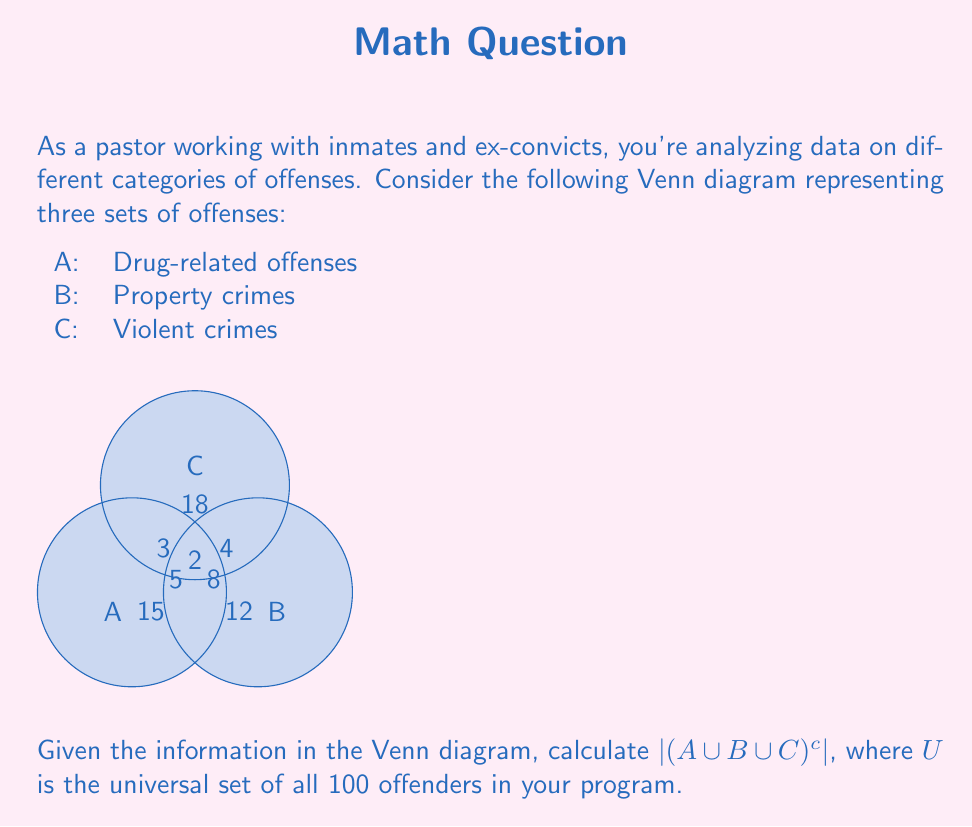Could you help me with this problem? Let's approach this step-by-step:

1) First, we need to find $|A \cup B \cup C|$, which represents the total number of offenders in at least one of these categories.

2) To calculate this, we'll use the principle of inclusion-exclusion:

   $|A \cup B \cup C| = |A| + |B| + |C| - |A \cap B| - |A \cap C| - |B \cap C| + |A \cap B \cap C|$

3) From the Venn diagram, we can extract:
   $|A| = 15 + 5 + 3 + 2 = 25$
   $|B| = 12 + 8 + 4 + 2 = 26$
   $|C| = 18 + 3 + 4 + 2 = 27$
   $|A \cap B| = 5 + 2 = 7$
   $|A \cap C| = 3 + 2 = 5$
   $|B \cap C| = 4 + 2 = 6$
   $|A \cap B \cap C| = 2$

4) Substituting these values:

   $|A \cup B \cup C| = 25 + 26 + 27 - 7 - 5 - 6 + 2 = 62$

5) Now, $|(A \cup B \cup C)^c|$ represents the number of offenders not in any of these categories.

6) Since the universal set $U$ contains 100 offenders, we can calculate:

   $|(A \cup B \cup C)^c| = |U| - |A \cup B \cup C| = 100 - 62 = 38$

Therefore, there are 38 offenders who are not in any of these three offense categories.
Answer: 38 